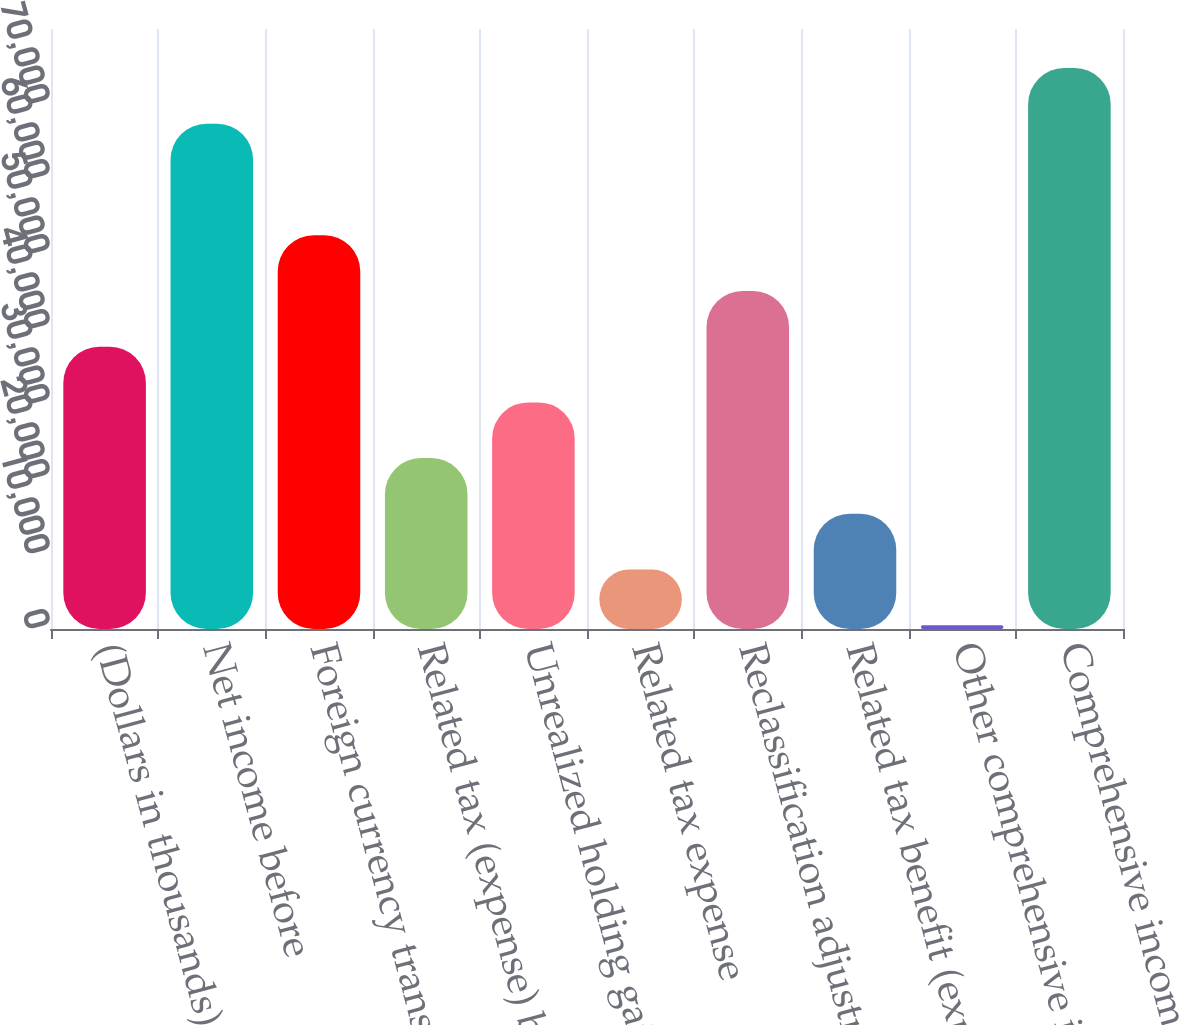Convert chart. <chart><loc_0><loc_0><loc_500><loc_500><bar_chart><fcel>(Dollars in thousands)<fcel>Net income before<fcel>Foreign currency translation<fcel>Related tax (expense) benefit<fcel>Unrealized holding gains<fcel>Related tax expense<fcel>Reclassification adjustment<fcel>Related tax benefit (expense)<fcel>Other comprehensive income net<fcel>Comprehensive income<nl><fcel>37644<fcel>67358.4<fcel>52501.2<fcel>22786.8<fcel>30215.4<fcel>7929.6<fcel>45072.6<fcel>15358.2<fcel>501<fcel>74787<nl></chart> 